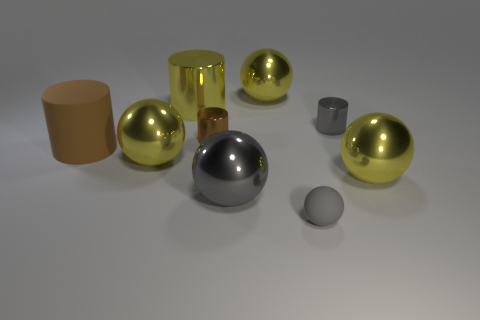What is the material of the tiny cylinder that is the same color as the rubber ball?
Give a very brief answer. Metal. What number of red things are matte things or rubber spheres?
Provide a short and direct response. 0. There is a small gray thing that is in front of the tiny shiny thing on the left side of the large gray ball; what is it made of?
Keep it short and to the point. Rubber. Is the small brown thing the same shape as the brown matte object?
Give a very brief answer. Yes. What is the color of the other metallic cylinder that is the same size as the brown metal cylinder?
Keep it short and to the point. Gray. Are there any big balls that have the same color as the small sphere?
Offer a terse response. Yes. Are any tiny blue rubber objects visible?
Make the answer very short. No. Is the material of the big sphere that is on the right side of the small gray rubber thing the same as the large brown cylinder?
Provide a short and direct response. No. There is a object that is the same color as the large matte cylinder; what is its size?
Keep it short and to the point. Small. What number of metal balls are the same size as the gray matte sphere?
Make the answer very short. 0. 